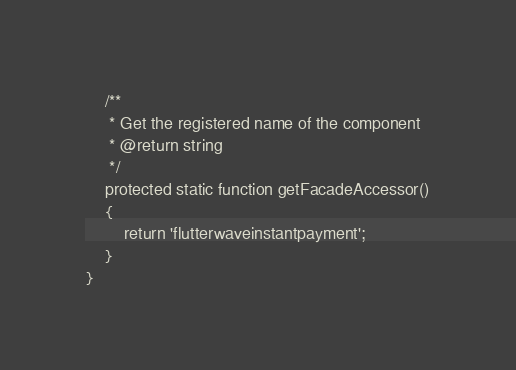<code> <loc_0><loc_0><loc_500><loc_500><_PHP_>    /**
     * Get the registered name of the component
     * @return string
     */
    protected static function getFacadeAccessor()
    {
        return 'flutterwaveinstantpayment';
    }
}
</code> 